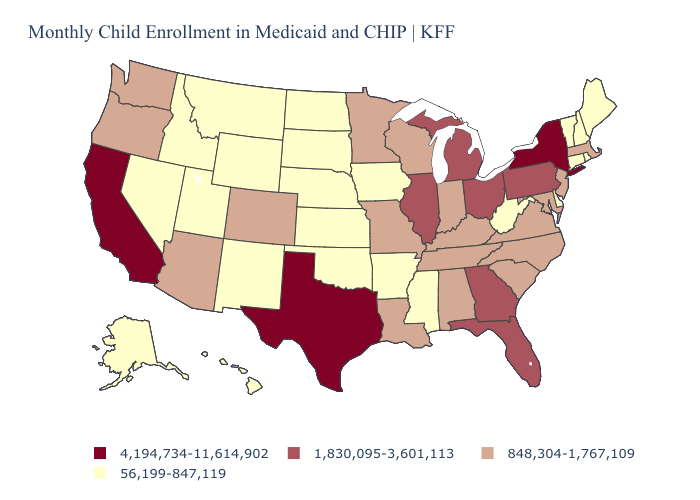Among the states that border Utah , which have the highest value?
Answer briefly. Arizona, Colorado. What is the highest value in the USA?
Short answer required. 4,194,734-11,614,902. What is the value of South Dakota?
Keep it brief. 56,199-847,119. What is the value of Alabama?
Give a very brief answer. 848,304-1,767,109. Name the states that have a value in the range 848,304-1,767,109?
Keep it brief. Alabama, Arizona, Colorado, Indiana, Kentucky, Louisiana, Maryland, Massachusetts, Minnesota, Missouri, New Jersey, North Carolina, Oregon, South Carolina, Tennessee, Virginia, Washington, Wisconsin. Name the states that have a value in the range 848,304-1,767,109?
Short answer required. Alabama, Arizona, Colorado, Indiana, Kentucky, Louisiana, Maryland, Massachusetts, Minnesota, Missouri, New Jersey, North Carolina, Oregon, South Carolina, Tennessee, Virginia, Washington, Wisconsin. Does Minnesota have a higher value than Arkansas?
Short answer required. Yes. Does Wyoming have the lowest value in the West?
Write a very short answer. Yes. Name the states that have a value in the range 56,199-847,119?
Answer briefly. Alaska, Arkansas, Connecticut, Delaware, Hawaii, Idaho, Iowa, Kansas, Maine, Mississippi, Montana, Nebraska, Nevada, New Hampshire, New Mexico, North Dakota, Oklahoma, Rhode Island, South Dakota, Utah, Vermont, West Virginia, Wyoming. Is the legend a continuous bar?
Keep it brief. No. Does the map have missing data?
Give a very brief answer. No. Name the states that have a value in the range 4,194,734-11,614,902?
Answer briefly. California, New York, Texas. Is the legend a continuous bar?
Write a very short answer. No. Does Connecticut have the lowest value in the Northeast?
Quick response, please. Yes. What is the lowest value in the USA?
Be succinct. 56,199-847,119. 